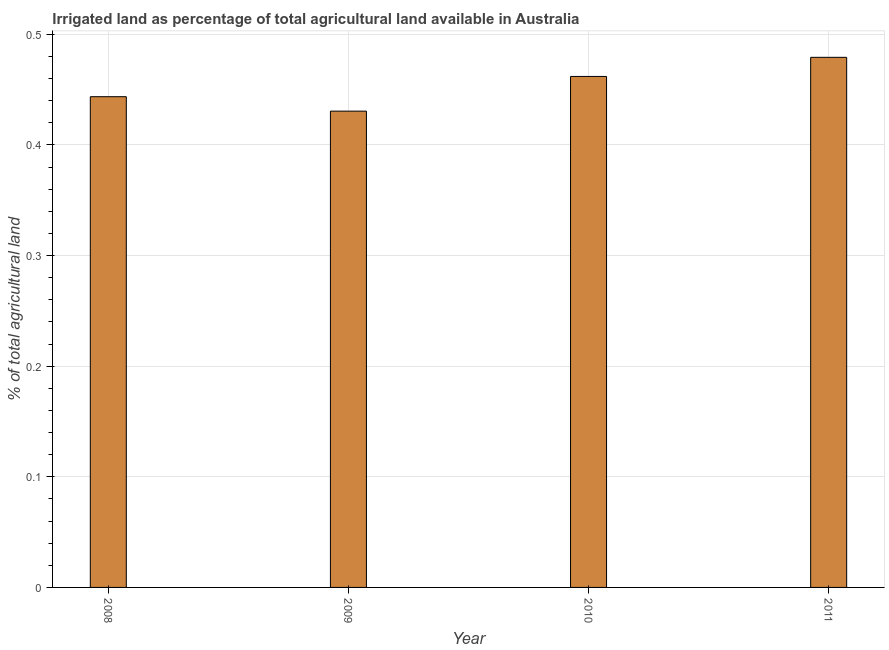Does the graph contain any zero values?
Provide a succinct answer. No. Does the graph contain grids?
Ensure brevity in your answer.  Yes. What is the title of the graph?
Provide a succinct answer. Irrigated land as percentage of total agricultural land available in Australia. What is the label or title of the Y-axis?
Offer a very short reply. % of total agricultural land. What is the percentage of agricultural irrigated land in 2011?
Your answer should be compact. 0.48. Across all years, what is the maximum percentage of agricultural irrigated land?
Provide a succinct answer. 0.48. Across all years, what is the minimum percentage of agricultural irrigated land?
Offer a very short reply. 0.43. What is the sum of the percentage of agricultural irrigated land?
Your answer should be very brief. 1.82. What is the difference between the percentage of agricultural irrigated land in 2008 and 2010?
Offer a terse response. -0.02. What is the average percentage of agricultural irrigated land per year?
Your answer should be very brief. 0.45. What is the median percentage of agricultural irrigated land?
Offer a very short reply. 0.45. Do a majority of the years between 2009 and 2011 (inclusive) have percentage of agricultural irrigated land greater than 0.4 %?
Your answer should be compact. Yes. What is the ratio of the percentage of agricultural irrigated land in 2009 to that in 2010?
Keep it short and to the point. 0.93. Is the percentage of agricultural irrigated land in 2010 less than that in 2011?
Your answer should be compact. Yes. Is the difference between the percentage of agricultural irrigated land in 2008 and 2009 greater than the difference between any two years?
Give a very brief answer. No. What is the difference between the highest and the second highest percentage of agricultural irrigated land?
Keep it short and to the point. 0.02. Is the sum of the percentage of agricultural irrigated land in 2008 and 2010 greater than the maximum percentage of agricultural irrigated land across all years?
Give a very brief answer. Yes. What is the difference between the highest and the lowest percentage of agricultural irrigated land?
Your response must be concise. 0.05. What is the % of total agricultural land of 2008?
Your response must be concise. 0.44. What is the % of total agricultural land in 2009?
Make the answer very short. 0.43. What is the % of total agricultural land of 2010?
Give a very brief answer. 0.46. What is the % of total agricultural land of 2011?
Keep it short and to the point. 0.48. What is the difference between the % of total agricultural land in 2008 and 2009?
Keep it short and to the point. 0.01. What is the difference between the % of total agricultural land in 2008 and 2010?
Keep it short and to the point. -0.02. What is the difference between the % of total agricultural land in 2008 and 2011?
Offer a very short reply. -0.04. What is the difference between the % of total agricultural land in 2009 and 2010?
Your answer should be very brief. -0.03. What is the difference between the % of total agricultural land in 2009 and 2011?
Give a very brief answer. -0.05. What is the difference between the % of total agricultural land in 2010 and 2011?
Give a very brief answer. -0.02. What is the ratio of the % of total agricultural land in 2008 to that in 2011?
Keep it short and to the point. 0.93. What is the ratio of the % of total agricultural land in 2009 to that in 2010?
Make the answer very short. 0.93. What is the ratio of the % of total agricultural land in 2009 to that in 2011?
Provide a short and direct response. 0.9. What is the ratio of the % of total agricultural land in 2010 to that in 2011?
Provide a succinct answer. 0.96. 